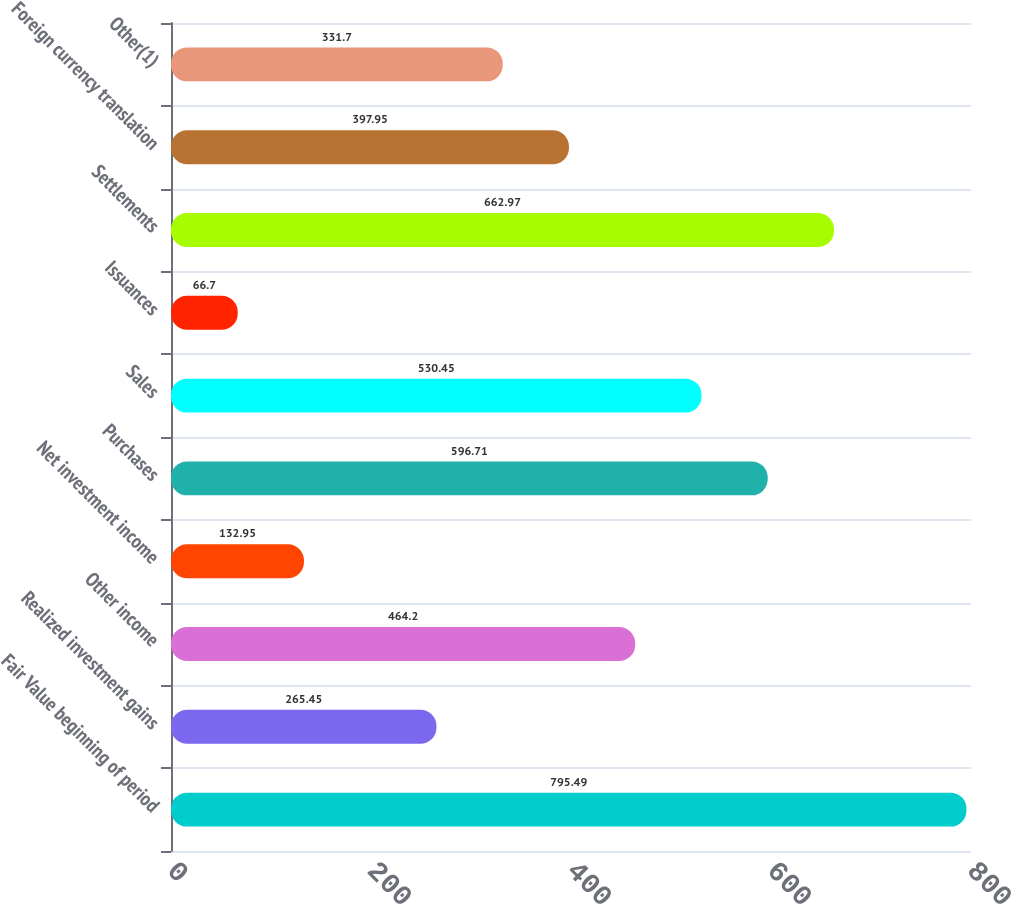Convert chart to OTSL. <chart><loc_0><loc_0><loc_500><loc_500><bar_chart><fcel>Fair Value beginning of period<fcel>Realized investment gains<fcel>Other income<fcel>Net investment income<fcel>Purchases<fcel>Sales<fcel>Issuances<fcel>Settlements<fcel>Foreign currency translation<fcel>Other(1)<nl><fcel>795.49<fcel>265.45<fcel>464.2<fcel>132.95<fcel>596.71<fcel>530.45<fcel>66.7<fcel>662.97<fcel>397.95<fcel>331.7<nl></chart> 